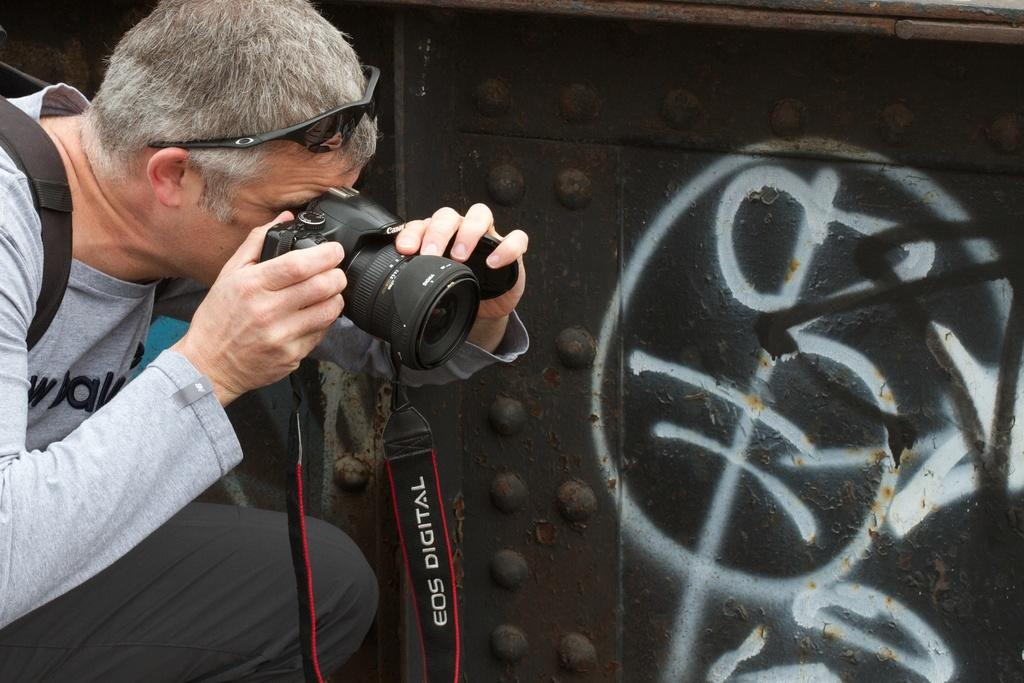What is the man in the image holding? The man in the image is holding a camera. Can you describe the man's appearance in the image? The man is wearing glasses on his head. Are there any other people in the image? No, the only person mentioned in the facts is the man holding the camera. What might the man be doing with the camera? The man might be taking photos or recording a video. How does the man in the image judge the quality of the pull? There is no mention of a pull or any judging activity in the image. The image only features a man holding a camera and wearing glasses on his head. 